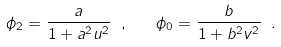Convert formula to latex. <formula><loc_0><loc_0><loc_500><loc_500>\phi _ { 2 } = \frac { a } { 1 + a ^ { 2 } u ^ { 2 } } \ , \quad \phi _ { 0 } = \frac { b } { 1 + b ^ { 2 } v ^ { 2 } } \ .</formula> 